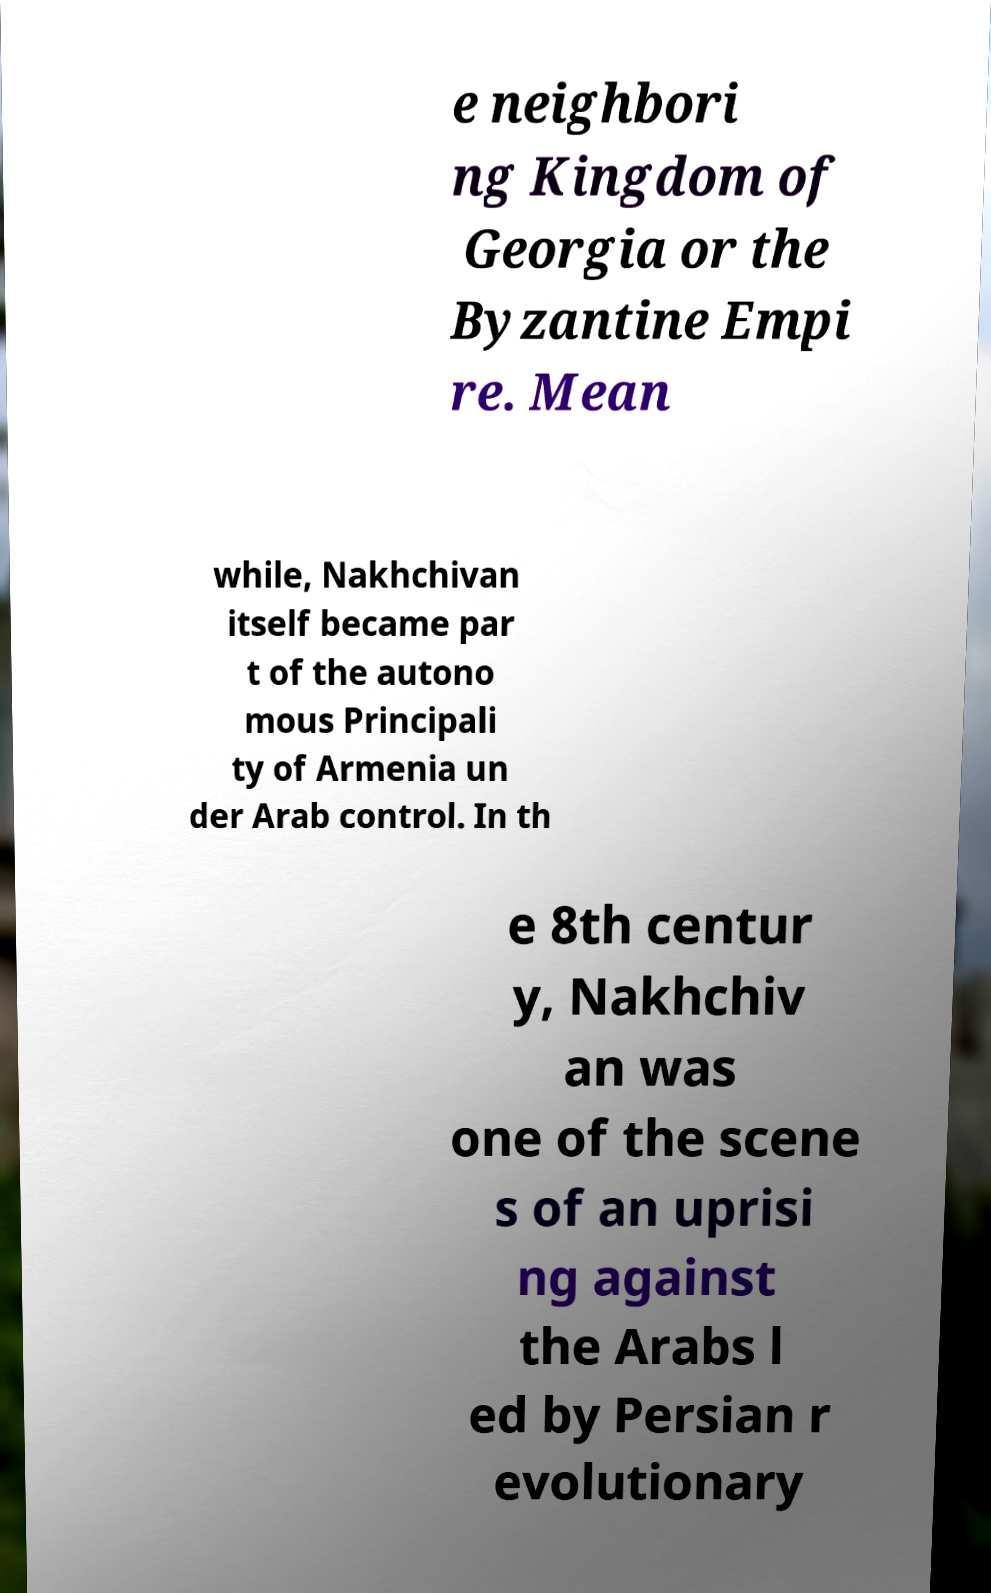Please identify and transcribe the text found in this image. e neighbori ng Kingdom of Georgia or the Byzantine Empi re. Mean while, Nakhchivan itself became par t of the autono mous Principali ty of Armenia un der Arab control. In th e 8th centur y, Nakhchiv an was one of the scene s of an uprisi ng against the Arabs l ed by Persian r evolutionary 